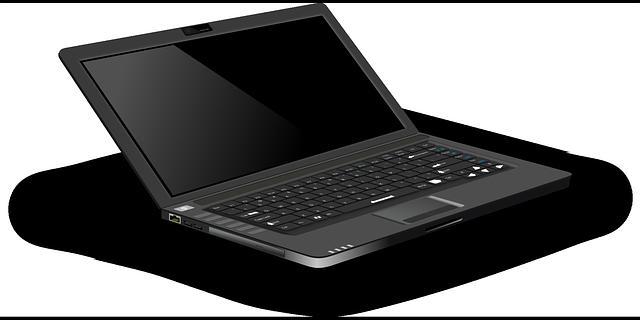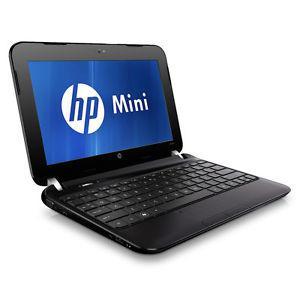The first image is the image on the left, the second image is the image on the right. Analyze the images presented: Is the assertion "Each image contains exactly one open laptop, and no laptop screen is disconnected from the base." valid? Answer yes or no. Yes. The first image is the image on the left, the second image is the image on the right. Analyze the images presented: Is the assertion "One of the laptops has a blank screen." valid? Answer yes or no. Yes. 